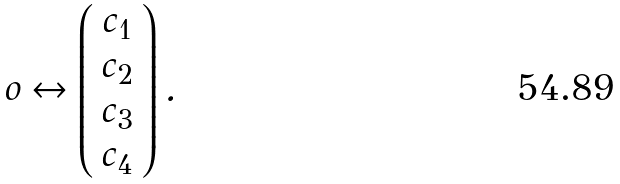<formula> <loc_0><loc_0><loc_500><loc_500>o \leftrightarrow \left ( \begin{array} { c } c _ { 1 } \\ c _ { 2 } \\ c _ { 3 } \\ c _ { 4 } \end{array} \right ) .</formula> 